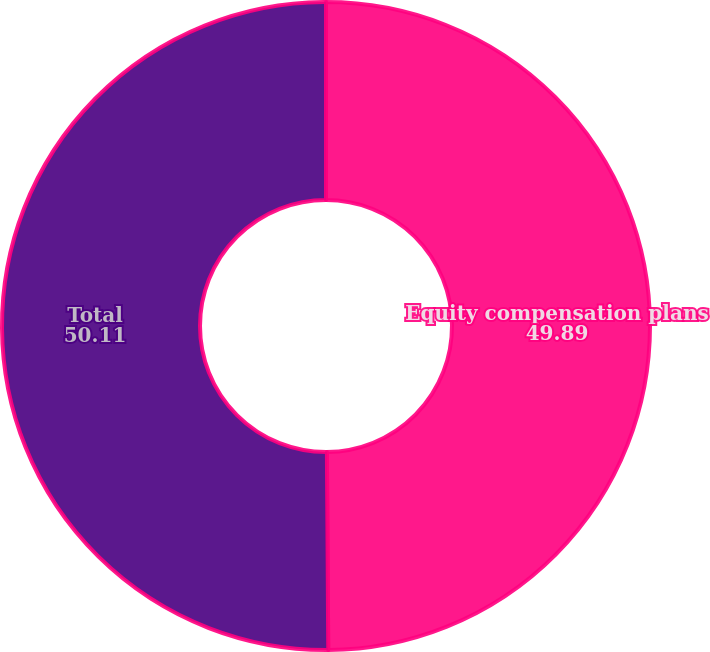Convert chart to OTSL. <chart><loc_0><loc_0><loc_500><loc_500><pie_chart><fcel>Equity compensation plans<fcel>Total<nl><fcel>49.89%<fcel>50.11%<nl></chart> 